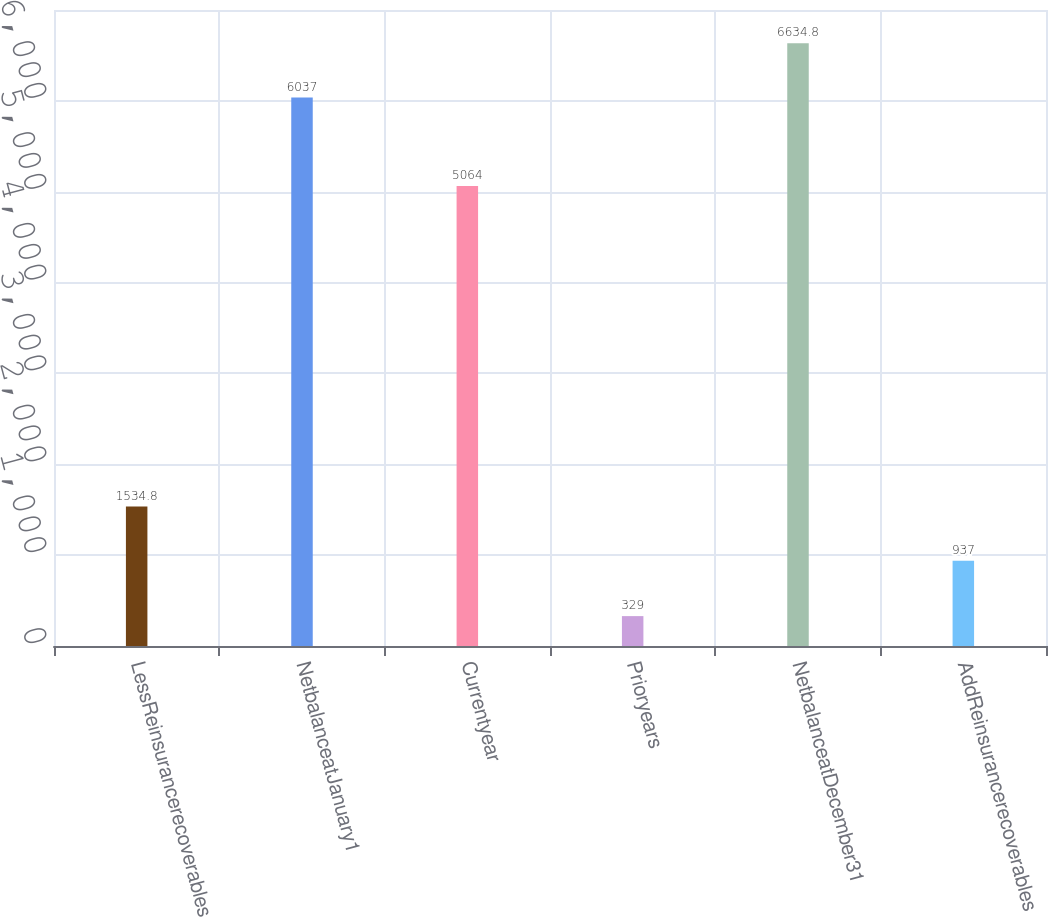Convert chart. <chart><loc_0><loc_0><loc_500><loc_500><bar_chart><fcel>LessReinsurancerecoverables<fcel>NetbalanceatJanuary1<fcel>Currentyear<fcel>Prioryears<fcel>NetbalanceatDecember31<fcel>AddReinsurancerecoverables<nl><fcel>1534.8<fcel>6037<fcel>5064<fcel>329<fcel>6634.8<fcel>937<nl></chart> 